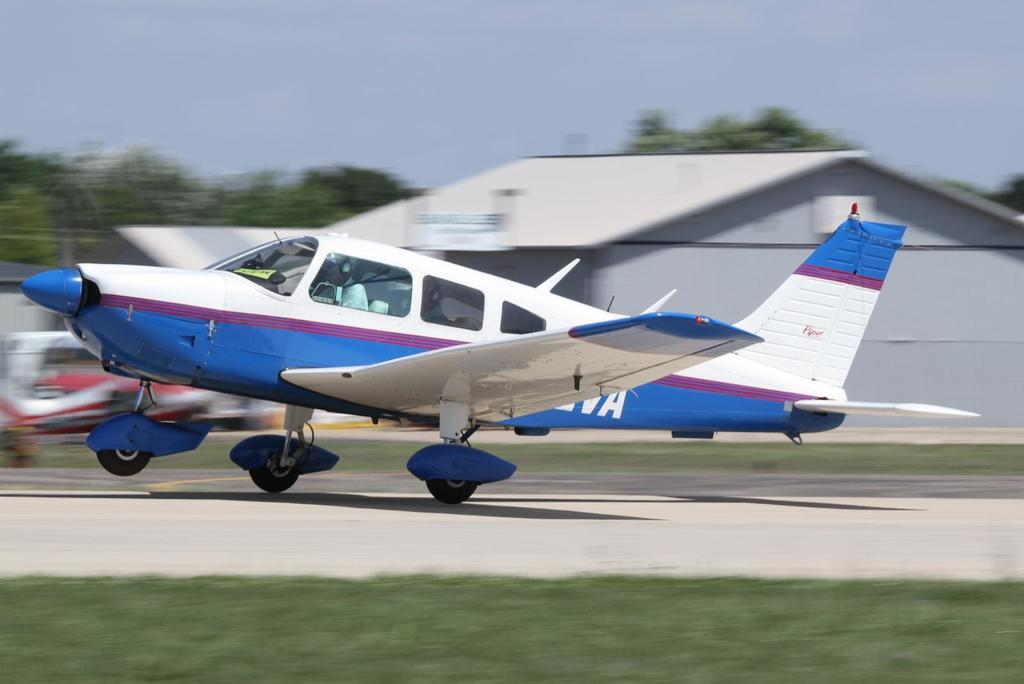What is the main subject of the image? The main subject of the image is an airplane on a runway. What can be seen in the background of the image? In the background of the image, there is a shed, trees, and the sky. What is the condition of the image? The image is blurred. What type of vegetation is in the foreground of the image? There is grass in the foreground of the image. Where is the fireman working in the image? There is no fireman present in the image. What type of crops is the farmer tending to in the image? There is no farmer or crops present in the image. 